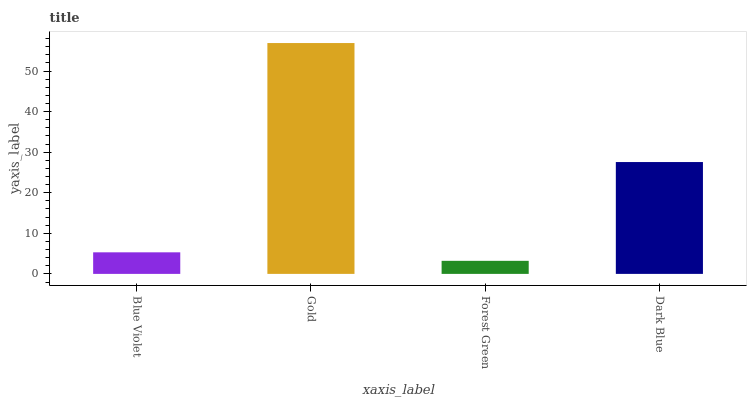Is Forest Green the minimum?
Answer yes or no. Yes. Is Gold the maximum?
Answer yes or no. Yes. Is Gold the minimum?
Answer yes or no. No. Is Forest Green the maximum?
Answer yes or no. No. Is Gold greater than Forest Green?
Answer yes or no. Yes. Is Forest Green less than Gold?
Answer yes or no. Yes. Is Forest Green greater than Gold?
Answer yes or no. No. Is Gold less than Forest Green?
Answer yes or no. No. Is Dark Blue the high median?
Answer yes or no. Yes. Is Blue Violet the low median?
Answer yes or no. Yes. Is Blue Violet the high median?
Answer yes or no. No. Is Dark Blue the low median?
Answer yes or no. No. 